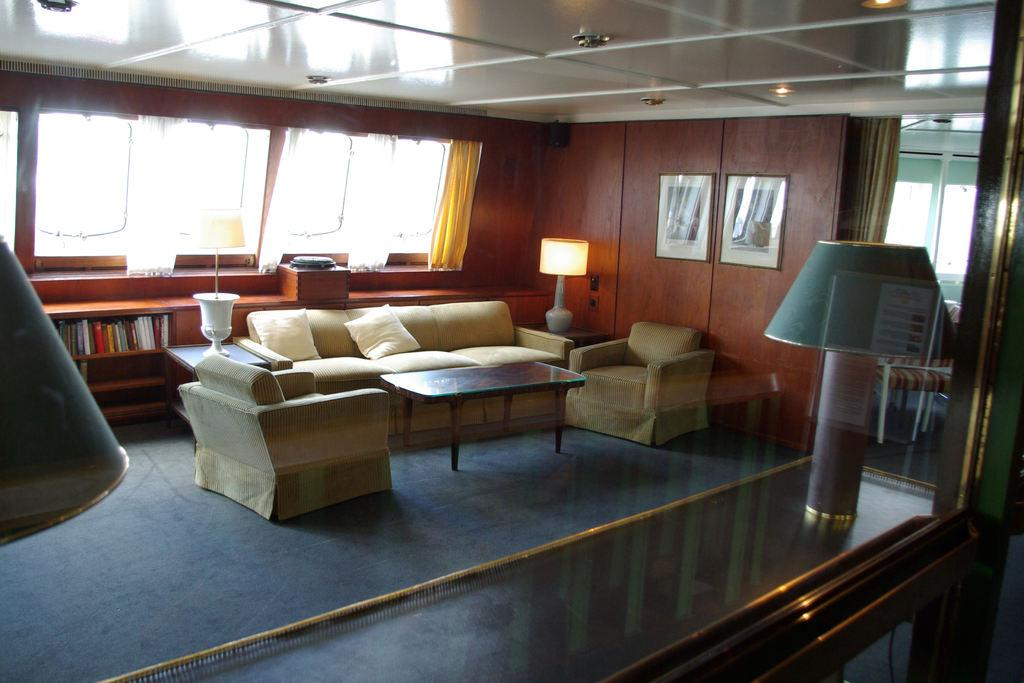What type of surface is the pictures hanging on in the image? The pictures are hanging on a wooden wall in the image. What items can be seen related to reading or learning in the image? There are books in the image. What type of furniture is present for seating in the image? There is a couch, chairs, and pillows in the image. What type of furniture is present for placing items in the image? There are tables in the image. What type of lighting is present in the image? There are lamps on the tables in the image. What type of architectural feature is present for natural light in the image? There are windows in the image. Can you tell me how many nerves are visible in the image? There are no nerves present in the image. What type of bubble can be seen floating near the windows in the image? There are no bubbles present in the image. 